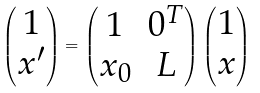<formula> <loc_0><loc_0><loc_500><loc_500>\begin{pmatrix} 1 \\ x ^ { \prime } \end{pmatrix} = \begin{pmatrix} 1 & 0 ^ { T } \\ x _ { 0 } & L \end{pmatrix} \begin{pmatrix} 1 \\ x \end{pmatrix}</formula> 